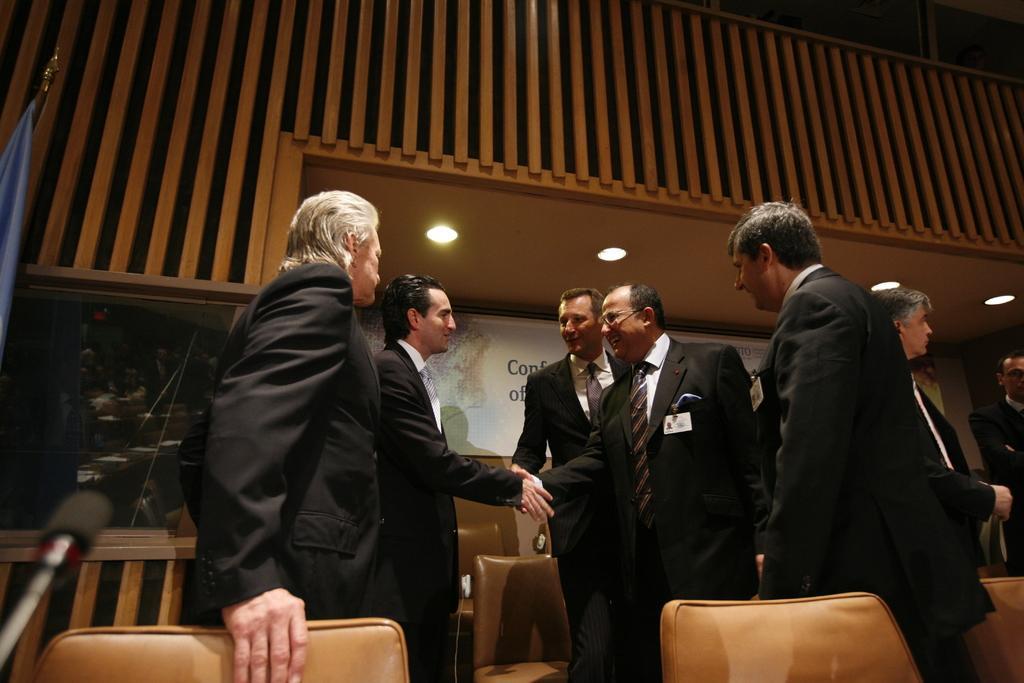Describe this image in one or two sentences. In the center of the image we can see two people shaking their hands. In the background there are people. At the top there are lights. At the bottom we can see chairs. On the left there is a mic and a flag 